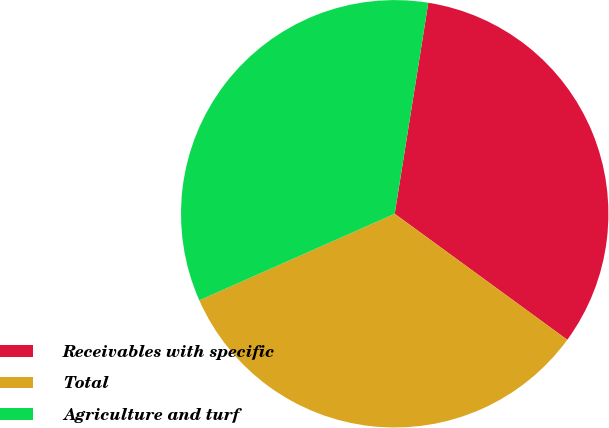<chart> <loc_0><loc_0><loc_500><loc_500><pie_chart><fcel>Receivables with specific<fcel>Total<fcel>Agriculture and turf<nl><fcel>32.52%<fcel>33.33%<fcel>34.15%<nl></chart> 